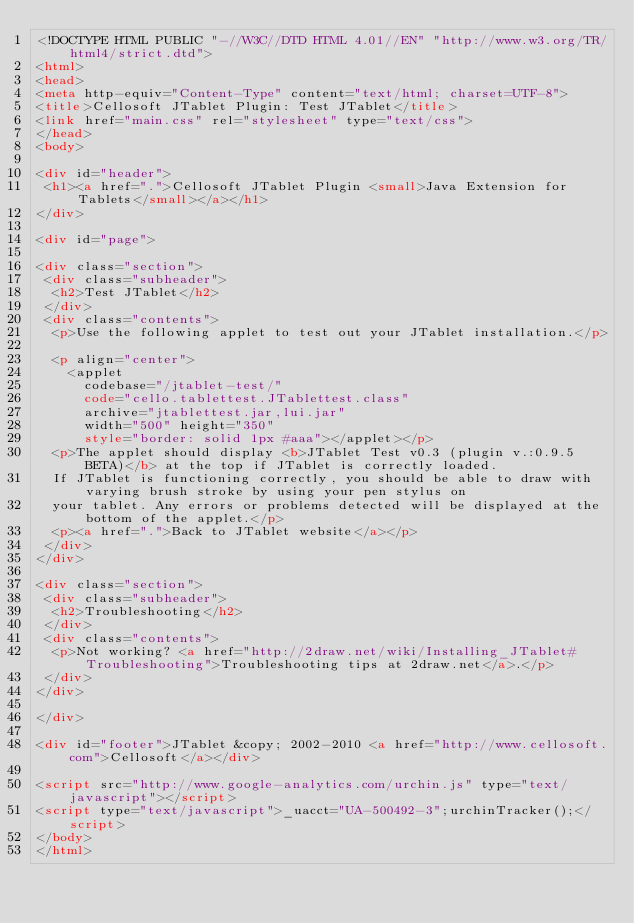Convert code to text. <code><loc_0><loc_0><loc_500><loc_500><_HTML_><!DOCTYPE HTML PUBLIC "-//W3C//DTD HTML 4.01//EN" "http://www.w3.org/TR/html4/strict.dtd">
<html>
<head>
<meta http-equiv="Content-Type" content="text/html; charset=UTF-8">
<title>Cellosoft JTablet Plugin: Test JTablet</title>
<link href="main.css" rel="stylesheet" type="text/css">
</head>
<body>

<div id="header">
 <h1><a href=".">Cellosoft JTablet Plugin <small>Java Extension for Tablets</small></a></h1>
</div>

<div id="page">

<div class="section">
 <div class="subheader">
  <h2>Test JTablet</h2>
 </div>
 <div class="contents">
  <p>Use the following applet to test out your JTablet installation.</p>

  <p align="center">
  	<applet 
  		codebase="/jtablet-test/" 
  		code="cello.tablettest.JTablettest.class" 
  		archive="jtablettest.jar,lui.jar" 
  		width="500" height="350"
  		style="border: solid 1px #aaa"></applet></p>
  <p>The applet should display <b>JTablet Test v0.3 (plugin v.:0.9.5 BETA)</b> at the top if JTablet is correctly loaded. 
  If JTablet is functioning correctly, you should be able to draw with varying brush stroke by using your pen stylus on 
  your tablet. Any errors or problems detected will be displayed at the bottom of the applet.</p>
  <p><a href=".">Back to JTablet website</a></p>
 </div>
</div>

<div class="section">
 <div class="subheader">
  <h2>Troubleshooting</h2>
 </div>
 <div class="contents">
  <p>Not working? <a href="http://2draw.net/wiki/Installing_JTablet#Troubleshooting">Troubleshooting tips at 2draw.net</a>.</p>
 </div>
</div>

</div>

<div id="footer">JTablet &copy; 2002-2010 <a href="http://www.cellosoft.com">Cellosoft</a></div>

<script src="http://www.google-analytics.com/urchin.js" type="text/javascript"></script>
<script type="text/javascript">_uacct="UA-500492-3";urchinTracker();</script>
</body>
</html>
</code> 